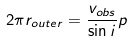<formula> <loc_0><loc_0><loc_500><loc_500>2 \pi r _ { o u t e r } = \frac { v _ { o b s } } { \sin i } p</formula> 